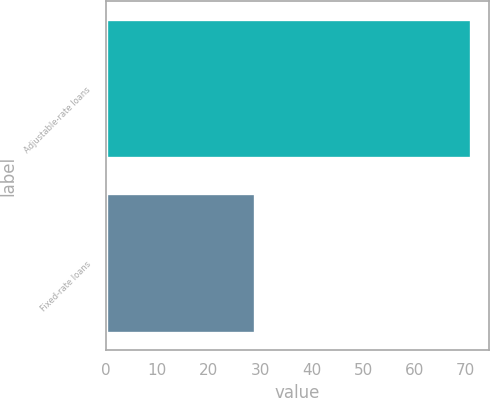Convert chart. <chart><loc_0><loc_0><loc_500><loc_500><bar_chart><fcel>Adjustable-rate loans<fcel>Fixed-rate loans<nl><fcel>71<fcel>29<nl></chart> 